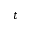<formula> <loc_0><loc_0><loc_500><loc_500>t</formula> 